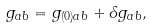Convert formula to latex. <formula><loc_0><loc_0><loc_500><loc_500>g _ { a b } = g _ { ( 0 ) a b } + \delta g _ { a b } ,</formula> 